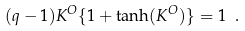Convert formula to latex. <formula><loc_0><loc_0><loc_500><loc_500>( q - 1 ) K ^ { O } \{ 1 + \tanh ( K ^ { O } ) \} = 1 \ .</formula> 